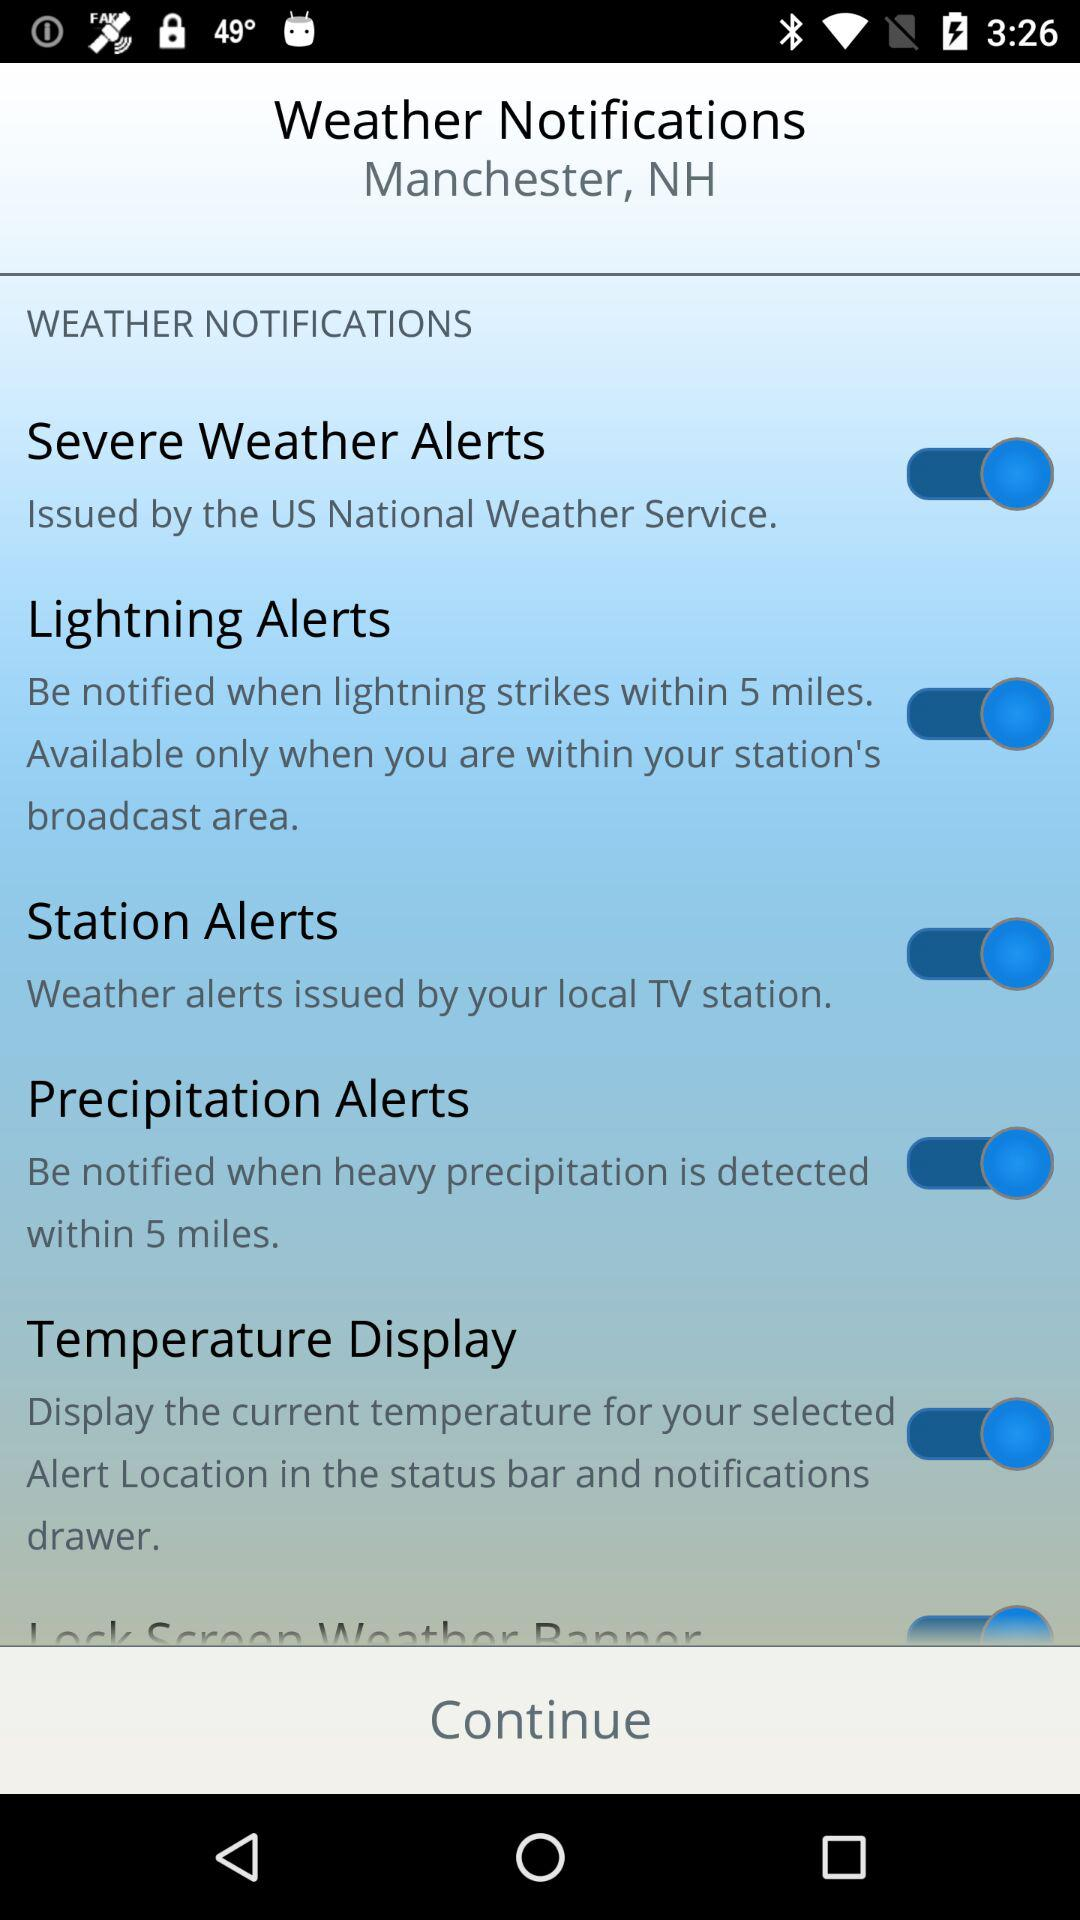What is the status of the "Lightning Alerts"? The status is "on". 